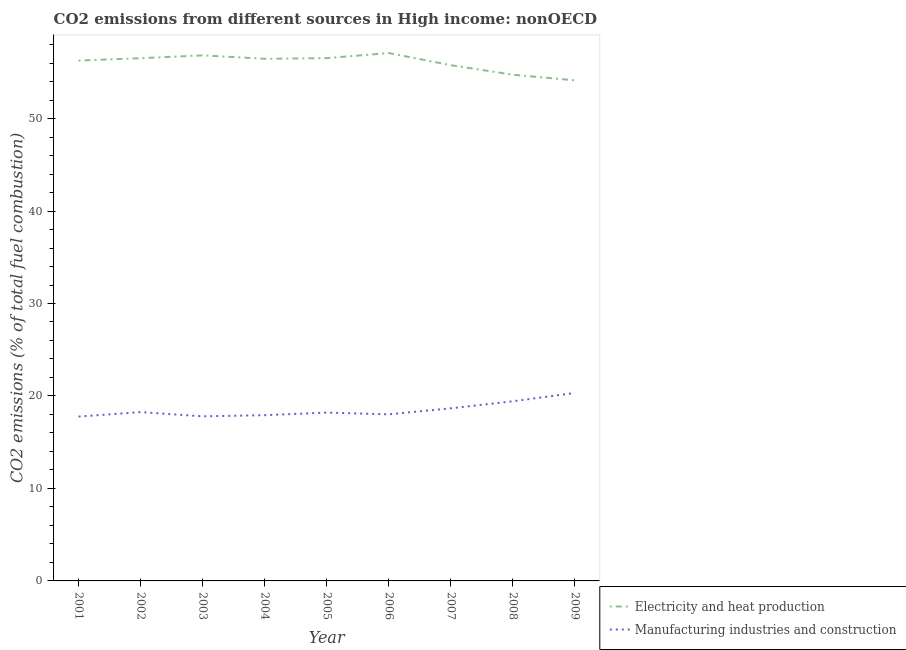What is the co2 emissions due to electricity and heat production in 2002?
Your answer should be very brief. 56.53. Across all years, what is the maximum co2 emissions due to manufacturing industries?
Offer a very short reply. 20.33. Across all years, what is the minimum co2 emissions due to manufacturing industries?
Offer a terse response. 17.77. In which year was the co2 emissions due to electricity and heat production minimum?
Provide a short and direct response. 2009. What is the total co2 emissions due to manufacturing industries in the graph?
Ensure brevity in your answer.  166.4. What is the difference between the co2 emissions due to manufacturing industries in 2006 and that in 2008?
Make the answer very short. -1.41. What is the difference between the co2 emissions due to electricity and heat production in 2004 and the co2 emissions due to manufacturing industries in 2008?
Make the answer very short. 37.03. What is the average co2 emissions due to manufacturing industries per year?
Provide a succinct answer. 18.49. In the year 2009, what is the difference between the co2 emissions due to electricity and heat production and co2 emissions due to manufacturing industries?
Ensure brevity in your answer.  33.8. What is the ratio of the co2 emissions due to electricity and heat production in 2006 to that in 2009?
Your response must be concise. 1.05. Is the co2 emissions due to electricity and heat production in 2005 less than that in 2006?
Your response must be concise. Yes. Is the difference between the co2 emissions due to electricity and heat production in 2003 and 2006 greater than the difference between the co2 emissions due to manufacturing industries in 2003 and 2006?
Keep it short and to the point. No. What is the difference between the highest and the second highest co2 emissions due to manufacturing industries?
Keep it short and to the point. 0.9. What is the difference between the highest and the lowest co2 emissions due to manufacturing industries?
Give a very brief answer. 2.56. In how many years, is the co2 emissions due to manufacturing industries greater than the average co2 emissions due to manufacturing industries taken over all years?
Make the answer very short. 3. Is the sum of the co2 emissions due to manufacturing industries in 2001 and 2003 greater than the maximum co2 emissions due to electricity and heat production across all years?
Ensure brevity in your answer.  No. Is the co2 emissions due to manufacturing industries strictly less than the co2 emissions due to electricity and heat production over the years?
Provide a short and direct response. Yes. How many lines are there?
Provide a succinct answer. 2. How many years are there in the graph?
Make the answer very short. 9. What is the difference between two consecutive major ticks on the Y-axis?
Keep it short and to the point. 10. Are the values on the major ticks of Y-axis written in scientific E-notation?
Keep it short and to the point. No. Does the graph contain any zero values?
Give a very brief answer. No. Where does the legend appear in the graph?
Your response must be concise. Bottom right. How many legend labels are there?
Give a very brief answer. 2. How are the legend labels stacked?
Your response must be concise. Vertical. What is the title of the graph?
Give a very brief answer. CO2 emissions from different sources in High income: nonOECD. What is the label or title of the Y-axis?
Offer a terse response. CO2 emissions (% of total fuel combustion). What is the CO2 emissions (% of total fuel combustion) in Electricity and heat production in 2001?
Offer a terse response. 56.27. What is the CO2 emissions (% of total fuel combustion) of Manufacturing industries and construction in 2001?
Give a very brief answer. 17.77. What is the CO2 emissions (% of total fuel combustion) of Electricity and heat production in 2002?
Give a very brief answer. 56.53. What is the CO2 emissions (% of total fuel combustion) of Manufacturing industries and construction in 2002?
Make the answer very short. 18.26. What is the CO2 emissions (% of total fuel combustion) of Electricity and heat production in 2003?
Your answer should be very brief. 56.83. What is the CO2 emissions (% of total fuel combustion) of Manufacturing industries and construction in 2003?
Ensure brevity in your answer.  17.8. What is the CO2 emissions (% of total fuel combustion) in Electricity and heat production in 2004?
Provide a short and direct response. 56.46. What is the CO2 emissions (% of total fuel combustion) in Manufacturing industries and construction in 2004?
Your answer should be compact. 17.92. What is the CO2 emissions (% of total fuel combustion) in Electricity and heat production in 2005?
Make the answer very short. 56.54. What is the CO2 emissions (% of total fuel combustion) in Manufacturing industries and construction in 2005?
Your answer should be very brief. 18.2. What is the CO2 emissions (% of total fuel combustion) of Electricity and heat production in 2006?
Offer a very short reply. 57.08. What is the CO2 emissions (% of total fuel combustion) of Manufacturing industries and construction in 2006?
Offer a terse response. 18.02. What is the CO2 emissions (% of total fuel combustion) of Electricity and heat production in 2007?
Your answer should be compact. 55.77. What is the CO2 emissions (% of total fuel combustion) of Manufacturing industries and construction in 2007?
Provide a short and direct response. 18.67. What is the CO2 emissions (% of total fuel combustion) of Electricity and heat production in 2008?
Provide a short and direct response. 54.74. What is the CO2 emissions (% of total fuel combustion) in Manufacturing industries and construction in 2008?
Provide a succinct answer. 19.43. What is the CO2 emissions (% of total fuel combustion) of Electricity and heat production in 2009?
Make the answer very short. 54.13. What is the CO2 emissions (% of total fuel combustion) in Manufacturing industries and construction in 2009?
Provide a short and direct response. 20.33. Across all years, what is the maximum CO2 emissions (% of total fuel combustion) in Electricity and heat production?
Your answer should be very brief. 57.08. Across all years, what is the maximum CO2 emissions (% of total fuel combustion) of Manufacturing industries and construction?
Make the answer very short. 20.33. Across all years, what is the minimum CO2 emissions (% of total fuel combustion) in Electricity and heat production?
Provide a short and direct response. 54.13. Across all years, what is the minimum CO2 emissions (% of total fuel combustion) in Manufacturing industries and construction?
Offer a terse response. 17.77. What is the total CO2 emissions (% of total fuel combustion) of Electricity and heat production in the graph?
Ensure brevity in your answer.  504.35. What is the total CO2 emissions (% of total fuel combustion) in Manufacturing industries and construction in the graph?
Ensure brevity in your answer.  166.4. What is the difference between the CO2 emissions (% of total fuel combustion) in Electricity and heat production in 2001 and that in 2002?
Your answer should be compact. -0.25. What is the difference between the CO2 emissions (% of total fuel combustion) in Manufacturing industries and construction in 2001 and that in 2002?
Your answer should be compact. -0.48. What is the difference between the CO2 emissions (% of total fuel combustion) of Electricity and heat production in 2001 and that in 2003?
Your answer should be very brief. -0.56. What is the difference between the CO2 emissions (% of total fuel combustion) in Manufacturing industries and construction in 2001 and that in 2003?
Your response must be concise. -0.03. What is the difference between the CO2 emissions (% of total fuel combustion) of Electricity and heat production in 2001 and that in 2004?
Give a very brief answer. -0.19. What is the difference between the CO2 emissions (% of total fuel combustion) of Manufacturing industries and construction in 2001 and that in 2004?
Your answer should be compact. -0.15. What is the difference between the CO2 emissions (% of total fuel combustion) of Electricity and heat production in 2001 and that in 2005?
Offer a terse response. -0.27. What is the difference between the CO2 emissions (% of total fuel combustion) of Manufacturing industries and construction in 2001 and that in 2005?
Keep it short and to the point. -0.43. What is the difference between the CO2 emissions (% of total fuel combustion) of Electricity and heat production in 2001 and that in 2006?
Keep it short and to the point. -0.81. What is the difference between the CO2 emissions (% of total fuel combustion) in Manufacturing industries and construction in 2001 and that in 2006?
Your response must be concise. -0.24. What is the difference between the CO2 emissions (% of total fuel combustion) in Electricity and heat production in 2001 and that in 2007?
Offer a very short reply. 0.5. What is the difference between the CO2 emissions (% of total fuel combustion) in Manufacturing industries and construction in 2001 and that in 2007?
Ensure brevity in your answer.  -0.9. What is the difference between the CO2 emissions (% of total fuel combustion) of Electricity and heat production in 2001 and that in 2008?
Keep it short and to the point. 1.53. What is the difference between the CO2 emissions (% of total fuel combustion) in Manufacturing industries and construction in 2001 and that in 2008?
Your answer should be compact. -1.66. What is the difference between the CO2 emissions (% of total fuel combustion) in Electricity and heat production in 2001 and that in 2009?
Offer a terse response. 2.14. What is the difference between the CO2 emissions (% of total fuel combustion) of Manufacturing industries and construction in 2001 and that in 2009?
Your answer should be compact. -2.56. What is the difference between the CO2 emissions (% of total fuel combustion) of Electricity and heat production in 2002 and that in 2003?
Offer a terse response. -0.31. What is the difference between the CO2 emissions (% of total fuel combustion) of Manufacturing industries and construction in 2002 and that in 2003?
Provide a short and direct response. 0.46. What is the difference between the CO2 emissions (% of total fuel combustion) in Electricity and heat production in 2002 and that in 2004?
Make the answer very short. 0.06. What is the difference between the CO2 emissions (% of total fuel combustion) in Manufacturing industries and construction in 2002 and that in 2004?
Your answer should be compact. 0.33. What is the difference between the CO2 emissions (% of total fuel combustion) in Electricity and heat production in 2002 and that in 2005?
Make the answer very short. -0.01. What is the difference between the CO2 emissions (% of total fuel combustion) of Manufacturing industries and construction in 2002 and that in 2005?
Your answer should be compact. 0.05. What is the difference between the CO2 emissions (% of total fuel combustion) of Electricity and heat production in 2002 and that in 2006?
Give a very brief answer. -0.56. What is the difference between the CO2 emissions (% of total fuel combustion) in Manufacturing industries and construction in 2002 and that in 2006?
Offer a very short reply. 0.24. What is the difference between the CO2 emissions (% of total fuel combustion) of Electricity and heat production in 2002 and that in 2007?
Offer a terse response. 0.76. What is the difference between the CO2 emissions (% of total fuel combustion) of Manufacturing industries and construction in 2002 and that in 2007?
Make the answer very short. -0.41. What is the difference between the CO2 emissions (% of total fuel combustion) in Electricity and heat production in 2002 and that in 2008?
Make the answer very short. 1.79. What is the difference between the CO2 emissions (% of total fuel combustion) of Manufacturing industries and construction in 2002 and that in 2008?
Provide a short and direct response. -1.17. What is the difference between the CO2 emissions (% of total fuel combustion) of Electricity and heat production in 2002 and that in 2009?
Your answer should be very brief. 2.4. What is the difference between the CO2 emissions (% of total fuel combustion) of Manufacturing industries and construction in 2002 and that in 2009?
Provide a short and direct response. -2.07. What is the difference between the CO2 emissions (% of total fuel combustion) in Electricity and heat production in 2003 and that in 2004?
Your answer should be compact. 0.37. What is the difference between the CO2 emissions (% of total fuel combustion) in Manufacturing industries and construction in 2003 and that in 2004?
Provide a succinct answer. -0.12. What is the difference between the CO2 emissions (% of total fuel combustion) in Electricity and heat production in 2003 and that in 2005?
Ensure brevity in your answer.  0.3. What is the difference between the CO2 emissions (% of total fuel combustion) in Manufacturing industries and construction in 2003 and that in 2005?
Offer a terse response. -0.4. What is the difference between the CO2 emissions (% of total fuel combustion) of Electricity and heat production in 2003 and that in 2006?
Ensure brevity in your answer.  -0.25. What is the difference between the CO2 emissions (% of total fuel combustion) of Manufacturing industries and construction in 2003 and that in 2006?
Your response must be concise. -0.22. What is the difference between the CO2 emissions (% of total fuel combustion) of Electricity and heat production in 2003 and that in 2007?
Your answer should be compact. 1.06. What is the difference between the CO2 emissions (% of total fuel combustion) of Manufacturing industries and construction in 2003 and that in 2007?
Your answer should be compact. -0.87. What is the difference between the CO2 emissions (% of total fuel combustion) in Electricity and heat production in 2003 and that in 2008?
Ensure brevity in your answer.  2.09. What is the difference between the CO2 emissions (% of total fuel combustion) of Manufacturing industries and construction in 2003 and that in 2008?
Make the answer very short. -1.63. What is the difference between the CO2 emissions (% of total fuel combustion) of Electricity and heat production in 2003 and that in 2009?
Your answer should be very brief. 2.7. What is the difference between the CO2 emissions (% of total fuel combustion) of Manufacturing industries and construction in 2003 and that in 2009?
Your response must be concise. -2.53. What is the difference between the CO2 emissions (% of total fuel combustion) of Electricity and heat production in 2004 and that in 2005?
Your answer should be very brief. -0.07. What is the difference between the CO2 emissions (% of total fuel combustion) in Manufacturing industries and construction in 2004 and that in 2005?
Your answer should be very brief. -0.28. What is the difference between the CO2 emissions (% of total fuel combustion) of Electricity and heat production in 2004 and that in 2006?
Provide a short and direct response. -0.62. What is the difference between the CO2 emissions (% of total fuel combustion) of Manufacturing industries and construction in 2004 and that in 2006?
Provide a short and direct response. -0.09. What is the difference between the CO2 emissions (% of total fuel combustion) in Electricity and heat production in 2004 and that in 2007?
Provide a short and direct response. 0.7. What is the difference between the CO2 emissions (% of total fuel combustion) of Manufacturing industries and construction in 2004 and that in 2007?
Ensure brevity in your answer.  -0.74. What is the difference between the CO2 emissions (% of total fuel combustion) in Electricity and heat production in 2004 and that in 2008?
Your response must be concise. 1.73. What is the difference between the CO2 emissions (% of total fuel combustion) in Manufacturing industries and construction in 2004 and that in 2008?
Provide a short and direct response. -1.51. What is the difference between the CO2 emissions (% of total fuel combustion) of Electricity and heat production in 2004 and that in 2009?
Your answer should be very brief. 2.33. What is the difference between the CO2 emissions (% of total fuel combustion) of Manufacturing industries and construction in 2004 and that in 2009?
Make the answer very short. -2.41. What is the difference between the CO2 emissions (% of total fuel combustion) of Electricity and heat production in 2005 and that in 2006?
Give a very brief answer. -0.55. What is the difference between the CO2 emissions (% of total fuel combustion) of Manufacturing industries and construction in 2005 and that in 2006?
Your response must be concise. 0.19. What is the difference between the CO2 emissions (% of total fuel combustion) in Electricity and heat production in 2005 and that in 2007?
Give a very brief answer. 0.77. What is the difference between the CO2 emissions (% of total fuel combustion) in Manufacturing industries and construction in 2005 and that in 2007?
Provide a short and direct response. -0.46. What is the difference between the CO2 emissions (% of total fuel combustion) of Electricity and heat production in 2005 and that in 2008?
Keep it short and to the point. 1.8. What is the difference between the CO2 emissions (% of total fuel combustion) in Manufacturing industries and construction in 2005 and that in 2008?
Provide a succinct answer. -1.23. What is the difference between the CO2 emissions (% of total fuel combustion) of Electricity and heat production in 2005 and that in 2009?
Provide a short and direct response. 2.41. What is the difference between the CO2 emissions (% of total fuel combustion) of Manufacturing industries and construction in 2005 and that in 2009?
Your answer should be very brief. -2.13. What is the difference between the CO2 emissions (% of total fuel combustion) of Electricity and heat production in 2006 and that in 2007?
Offer a terse response. 1.31. What is the difference between the CO2 emissions (% of total fuel combustion) in Manufacturing industries and construction in 2006 and that in 2007?
Offer a very short reply. -0.65. What is the difference between the CO2 emissions (% of total fuel combustion) in Electricity and heat production in 2006 and that in 2008?
Ensure brevity in your answer.  2.34. What is the difference between the CO2 emissions (% of total fuel combustion) of Manufacturing industries and construction in 2006 and that in 2008?
Offer a very short reply. -1.41. What is the difference between the CO2 emissions (% of total fuel combustion) of Electricity and heat production in 2006 and that in 2009?
Ensure brevity in your answer.  2.95. What is the difference between the CO2 emissions (% of total fuel combustion) in Manufacturing industries and construction in 2006 and that in 2009?
Offer a very short reply. -2.31. What is the difference between the CO2 emissions (% of total fuel combustion) in Manufacturing industries and construction in 2007 and that in 2008?
Offer a terse response. -0.76. What is the difference between the CO2 emissions (% of total fuel combustion) in Electricity and heat production in 2007 and that in 2009?
Your answer should be compact. 1.64. What is the difference between the CO2 emissions (% of total fuel combustion) in Manufacturing industries and construction in 2007 and that in 2009?
Provide a short and direct response. -1.66. What is the difference between the CO2 emissions (% of total fuel combustion) of Electricity and heat production in 2008 and that in 2009?
Make the answer very short. 0.61. What is the difference between the CO2 emissions (% of total fuel combustion) of Manufacturing industries and construction in 2008 and that in 2009?
Ensure brevity in your answer.  -0.9. What is the difference between the CO2 emissions (% of total fuel combustion) of Electricity and heat production in 2001 and the CO2 emissions (% of total fuel combustion) of Manufacturing industries and construction in 2002?
Offer a very short reply. 38.02. What is the difference between the CO2 emissions (% of total fuel combustion) in Electricity and heat production in 2001 and the CO2 emissions (% of total fuel combustion) in Manufacturing industries and construction in 2003?
Your response must be concise. 38.47. What is the difference between the CO2 emissions (% of total fuel combustion) in Electricity and heat production in 2001 and the CO2 emissions (% of total fuel combustion) in Manufacturing industries and construction in 2004?
Your answer should be compact. 38.35. What is the difference between the CO2 emissions (% of total fuel combustion) of Electricity and heat production in 2001 and the CO2 emissions (% of total fuel combustion) of Manufacturing industries and construction in 2005?
Make the answer very short. 38.07. What is the difference between the CO2 emissions (% of total fuel combustion) in Electricity and heat production in 2001 and the CO2 emissions (% of total fuel combustion) in Manufacturing industries and construction in 2006?
Make the answer very short. 38.26. What is the difference between the CO2 emissions (% of total fuel combustion) of Electricity and heat production in 2001 and the CO2 emissions (% of total fuel combustion) of Manufacturing industries and construction in 2007?
Ensure brevity in your answer.  37.6. What is the difference between the CO2 emissions (% of total fuel combustion) in Electricity and heat production in 2001 and the CO2 emissions (% of total fuel combustion) in Manufacturing industries and construction in 2008?
Your answer should be very brief. 36.84. What is the difference between the CO2 emissions (% of total fuel combustion) of Electricity and heat production in 2001 and the CO2 emissions (% of total fuel combustion) of Manufacturing industries and construction in 2009?
Offer a very short reply. 35.94. What is the difference between the CO2 emissions (% of total fuel combustion) in Electricity and heat production in 2002 and the CO2 emissions (% of total fuel combustion) in Manufacturing industries and construction in 2003?
Offer a very short reply. 38.73. What is the difference between the CO2 emissions (% of total fuel combustion) of Electricity and heat production in 2002 and the CO2 emissions (% of total fuel combustion) of Manufacturing industries and construction in 2004?
Give a very brief answer. 38.6. What is the difference between the CO2 emissions (% of total fuel combustion) of Electricity and heat production in 2002 and the CO2 emissions (% of total fuel combustion) of Manufacturing industries and construction in 2005?
Your answer should be very brief. 38.32. What is the difference between the CO2 emissions (% of total fuel combustion) of Electricity and heat production in 2002 and the CO2 emissions (% of total fuel combustion) of Manufacturing industries and construction in 2006?
Offer a very short reply. 38.51. What is the difference between the CO2 emissions (% of total fuel combustion) of Electricity and heat production in 2002 and the CO2 emissions (% of total fuel combustion) of Manufacturing industries and construction in 2007?
Your answer should be compact. 37.86. What is the difference between the CO2 emissions (% of total fuel combustion) in Electricity and heat production in 2002 and the CO2 emissions (% of total fuel combustion) in Manufacturing industries and construction in 2008?
Ensure brevity in your answer.  37.1. What is the difference between the CO2 emissions (% of total fuel combustion) of Electricity and heat production in 2002 and the CO2 emissions (% of total fuel combustion) of Manufacturing industries and construction in 2009?
Provide a short and direct response. 36.2. What is the difference between the CO2 emissions (% of total fuel combustion) of Electricity and heat production in 2003 and the CO2 emissions (% of total fuel combustion) of Manufacturing industries and construction in 2004?
Provide a succinct answer. 38.91. What is the difference between the CO2 emissions (% of total fuel combustion) of Electricity and heat production in 2003 and the CO2 emissions (% of total fuel combustion) of Manufacturing industries and construction in 2005?
Your answer should be compact. 38.63. What is the difference between the CO2 emissions (% of total fuel combustion) in Electricity and heat production in 2003 and the CO2 emissions (% of total fuel combustion) in Manufacturing industries and construction in 2006?
Provide a short and direct response. 38.82. What is the difference between the CO2 emissions (% of total fuel combustion) of Electricity and heat production in 2003 and the CO2 emissions (% of total fuel combustion) of Manufacturing industries and construction in 2007?
Offer a terse response. 38.17. What is the difference between the CO2 emissions (% of total fuel combustion) in Electricity and heat production in 2003 and the CO2 emissions (% of total fuel combustion) in Manufacturing industries and construction in 2008?
Provide a succinct answer. 37.4. What is the difference between the CO2 emissions (% of total fuel combustion) of Electricity and heat production in 2003 and the CO2 emissions (% of total fuel combustion) of Manufacturing industries and construction in 2009?
Give a very brief answer. 36.5. What is the difference between the CO2 emissions (% of total fuel combustion) of Electricity and heat production in 2004 and the CO2 emissions (% of total fuel combustion) of Manufacturing industries and construction in 2005?
Give a very brief answer. 38.26. What is the difference between the CO2 emissions (% of total fuel combustion) in Electricity and heat production in 2004 and the CO2 emissions (% of total fuel combustion) in Manufacturing industries and construction in 2006?
Provide a short and direct response. 38.45. What is the difference between the CO2 emissions (% of total fuel combustion) in Electricity and heat production in 2004 and the CO2 emissions (% of total fuel combustion) in Manufacturing industries and construction in 2007?
Give a very brief answer. 37.8. What is the difference between the CO2 emissions (% of total fuel combustion) of Electricity and heat production in 2004 and the CO2 emissions (% of total fuel combustion) of Manufacturing industries and construction in 2008?
Keep it short and to the point. 37.03. What is the difference between the CO2 emissions (% of total fuel combustion) in Electricity and heat production in 2004 and the CO2 emissions (% of total fuel combustion) in Manufacturing industries and construction in 2009?
Keep it short and to the point. 36.14. What is the difference between the CO2 emissions (% of total fuel combustion) of Electricity and heat production in 2005 and the CO2 emissions (% of total fuel combustion) of Manufacturing industries and construction in 2006?
Keep it short and to the point. 38.52. What is the difference between the CO2 emissions (% of total fuel combustion) of Electricity and heat production in 2005 and the CO2 emissions (% of total fuel combustion) of Manufacturing industries and construction in 2007?
Offer a very short reply. 37.87. What is the difference between the CO2 emissions (% of total fuel combustion) in Electricity and heat production in 2005 and the CO2 emissions (% of total fuel combustion) in Manufacturing industries and construction in 2008?
Ensure brevity in your answer.  37.11. What is the difference between the CO2 emissions (% of total fuel combustion) in Electricity and heat production in 2005 and the CO2 emissions (% of total fuel combustion) in Manufacturing industries and construction in 2009?
Your answer should be very brief. 36.21. What is the difference between the CO2 emissions (% of total fuel combustion) of Electricity and heat production in 2006 and the CO2 emissions (% of total fuel combustion) of Manufacturing industries and construction in 2007?
Make the answer very short. 38.42. What is the difference between the CO2 emissions (% of total fuel combustion) in Electricity and heat production in 2006 and the CO2 emissions (% of total fuel combustion) in Manufacturing industries and construction in 2008?
Your response must be concise. 37.65. What is the difference between the CO2 emissions (% of total fuel combustion) in Electricity and heat production in 2006 and the CO2 emissions (% of total fuel combustion) in Manufacturing industries and construction in 2009?
Your response must be concise. 36.75. What is the difference between the CO2 emissions (% of total fuel combustion) of Electricity and heat production in 2007 and the CO2 emissions (% of total fuel combustion) of Manufacturing industries and construction in 2008?
Provide a short and direct response. 36.34. What is the difference between the CO2 emissions (% of total fuel combustion) in Electricity and heat production in 2007 and the CO2 emissions (% of total fuel combustion) in Manufacturing industries and construction in 2009?
Offer a very short reply. 35.44. What is the difference between the CO2 emissions (% of total fuel combustion) in Electricity and heat production in 2008 and the CO2 emissions (% of total fuel combustion) in Manufacturing industries and construction in 2009?
Your answer should be very brief. 34.41. What is the average CO2 emissions (% of total fuel combustion) of Electricity and heat production per year?
Provide a succinct answer. 56.04. What is the average CO2 emissions (% of total fuel combustion) of Manufacturing industries and construction per year?
Keep it short and to the point. 18.49. In the year 2001, what is the difference between the CO2 emissions (% of total fuel combustion) in Electricity and heat production and CO2 emissions (% of total fuel combustion) in Manufacturing industries and construction?
Your answer should be very brief. 38.5. In the year 2002, what is the difference between the CO2 emissions (% of total fuel combustion) in Electricity and heat production and CO2 emissions (% of total fuel combustion) in Manufacturing industries and construction?
Your answer should be very brief. 38.27. In the year 2003, what is the difference between the CO2 emissions (% of total fuel combustion) of Electricity and heat production and CO2 emissions (% of total fuel combustion) of Manufacturing industries and construction?
Your response must be concise. 39.03. In the year 2004, what is the difference between the CO2 emissions (% of total fuel combustion) in Electricity and heat production and CO2 emissions (% of total fuel combustion) in Manufacturing industries and construction?
Give a very brief answer. 38.54. In the year 2005, what is the difference between the CO2 emissions (% of total fuel combustion) of Electricity and heat production and CO2 emissions (% of total fuel combustion) of Manufacturing industries and construction?
Your answer should be compact. 38.33. In the year 2006, what is the difference between the CO2 emissions (% of total fuel combustion) in Electricity and heat production and CO2 emissions (% of total fuel combustion) in Manufacturing industries and construction?
Your response must be concise. 39.07. In the year 2007, what is the difference between the CO2 emissions (% of total fuel combustion) in Electricity and heat production and CO2 emissions (% of total fuel combustion) in Manufacturing industries and construction?
Offer a very short reply. 37.1. In the year 2008, what is the difference between the CO2 emissions (% of total fuel combustion) in Electricity and heat production and CO2 emissions (% of total fuel combustion) in Manufacturing industries and construction?
Offer a terse response. 35.31. In the year 2009, what is the difference between the CO2 emissions (% of total fuel combustion) of Electricity and heat production and CO2 emissions (% of total fuel combustion) of Manufacturing industries and construction?
Give a very brief answer. 33.8. What is the ratio of the CO2 emissions (% of total fuel combustion) in Electricity and heat production in 2001 to that in 2002?
Your answer should be compact. 1. What is the ratio of the CO2 emissions (% of total fuel combustion) of Manufacturing industries and construction in 2001 to that in 2002?
Offer a very short reply. 0.97. What is the ratio of the CO2 emissions (% of total fuel combustion) in Manufacturing industries and construction in 2001 to that in 2005?
Offer a terse response. 0.98. What is the ratio of the CO2 emissions (% of total fuel combustion) in Electricity and heat production in 2001 to that in 2006?
Offer a terse response. 0.99. What is the ratio of the CO2 emissions (% of total fuel combustion) in Manufacturing industries and construction in 2001 to that in 2006?
Offer a very short reply. 0.99. What is the ratio of the CO2 emissions (% of total fuel combustion) in Electricity and heat production in 2001 to that in 2007?
Provide a short and direct response. 1.01. What is the ratio of the CO2 emissions (% of total fuel combustion) of Manufacturing industries and construction in 2001 to that in 2007?
Provide a succinct answer. 0.95. What is the ratio of the CO2 emissions (% of total fuel combustion) in Electricity and heat production in 2001 to that in 2008?
Offer a very short reply. 1.03. What is the ratio of the CO2 emissions (% of total fuel combustion) in Manufacturing industries and construction in 2001 to that in 2008?
Provide a succinct answer. 0.91. What is the ratio of the CO2 emissions (% of total fuel combustion) of Electricity and heat production in 2001 to that in 2009?
Your answer should be very brief. 1.04. What is the ratio of the CO2 emissions (% of total fuel combustion) of Manufacturing industries and construction in 2001 to that in 2009?
Offer a terse response. 0.87. What is the ratio of the CO2 emissions (% of total fuel combustion) in Manufacturing industries and construction in 2002 to that in 2003?
Your answer should be very brief. 1.03. What is the ratio of the CO2 emissions (% of total fuel combustion) in Manufacturing industries and construction in 2002 to that in 2004?
Provide a short and direct response. 1.02. What is the ratio of the CO2 emissions (% of total fuel combustion) in Electricity and heat production in 2002 to that in 2005?
Offer a terse response. 1. What is the ratio of the CO2 emissions (% of total fuel combustion) of Electricity and heat production in 2002 to that in 2006?
Provide a short and direct response. 0.99. What is the ratio of the CO2 emissions (% of total fuel combustion) in Manufacturing industries and construction in 2002 to that in 2006?
Provide a short and direct response. 1.01. What is the ratio of the CO2 emissions (% of total fuel combustion) in Electricity and heat production in 2002 to that in 2007?
Your answer should be compact. 1.01. What is the ratio of the CO2 emissions (% of total fuel combustion) in Manufacturing industries and construction in 2002 to that in 2007?
Give a very brief answer. 0.98. What is the ratio of the CO2 emissions (% of total fuel combustion) in Electricity and heat production in 2002 to that in 2008?
Provide a short and direct response. 1.03. What is the ratio of the CO2 emissions (% of total fuel combustion) of Manufacturing industries and construction in 2002 to that in 2008?
Your answer should be very brief. 0.94. What is the ratio of the CO2 emissions (% of total fuel combustion) of Electricity and heat production in 2002 to that in 2009?
Offer a very short reply. 1.04. What is the ratio of the CO2 emissions (% of total fuel combustion) in Manufacturing industries and construction in 2002 to that in 2009?
Ensure brevity in your answer.  0.9. What is the ratio of the CO2 emissions (% of total fuel combustion) in Electricity and heat production in 2003 to that in 2004?
Give a very brief answer. 1.01. What is the ratio of the CO2 emissions (% of total fuel combustion) in Manufacturing industries and construction in 2003 to that in 2004?
Your response must be concise. 0.99. What is the ratio of the CO2 emissions (% of total fuel combustion) of Manufacturing industries and construction in 2003 to that in 2005?
Your response must be concise. 0.98. What is the ratio of the CO2 emissions (% of total fuel combustion) in Electricity and heat production in 2003 to that in 2006?
Offer a terse response. 1. What is the ratio of the CO2 emissions (% of total fuel combustion) of Manufacturing industries and construction in 2003 to that in 2006?
Provide a short and direct response. 0.99. What is the ratio of the CO2 emissions (% of total fuel combustion) of Electricity and heat production in 2003 to that in 2007?
Your response must be concise. 1.02. What is the ratio of the CO2 emissions (% of total fuel combustion) of Manufacturing industries and construction in 2003 to that in 2007?
Your answer should be very brief. 0.95. What is the ratio of the CO2 emissions (% of total fuel combustion) in Electricity and heat production in 2003 to that in 2008?
Your answer should be very brief. 1.04. What is the ratio of the CO2 emissions (% of total fuel combustion) of Manufacturing industries and construction in 2003 to that in 2008?
Your answer should be very brief. 0.92. What is the ratio of the CO2 emissions (% of total fuel combustion) in Electricity and heat production in 2003 to that in 2009?
Your answer should be very brief. 1.05. What is the ratio of the CO2 emissions (% of total fuel combustion) of Manufacturing industries and construction in 2003 to that in 2009?
Provide a short and direct response. 0.88. What is the ratio of the CO2 emissions (% of total fuel combustion) in Electricity and heat production in 2004 to that in 2005?
Your answer should be very brief. 1. What is the ratio of the CO2 emissions (% of total fuel combustion) of Manufacturing industries and construction in 2004 to that in 2005?
Your answer should be compact. 0.98. What is the ratio of the CO2 emissions (% of total fuel combustion) of Manufacturing industries and construction in 2004 to that in 2006?
Keep it short and to the point. 0.99. What is the ratio of the CO2 emissions (% of total fuel combustion) of Electricity and heat production in 2004 to that in 2007?
Provide a short and direct response. 1.01. What is the ratio of the CO2 emissions (% of total fuel combustion) in Manufacturing industries and construction in 2004 to that in 2007?
Make the answer very short. 0.96. What is the ratio of the CO2 emissions (% of total fuel combustion) in Electricity and heat production in 2004 to that in 2008?
Your answer should be compact. 1.03. What is the ratio of the CO2 emissions (% of total fuel combustion) in Manufacturing industries and construction in 2004 to that in 2008?
Give a very brief answer. 0.92. What is the ratio of the CO2 emissions (% of total fuel combustion) of Electricity and heat production in 2004 to that in 2009?
Keep it short and to the point. 1.04. What is the ratio of the CO2 emissions (% of total fuel combustion) in Manufacturing industries and construction in 2004 to that in 2009?
Provide a succinct answer. 0.88. What is the ratio of the CO2 emissions (% of total fuel combustion) of Manufacturing industries and construction in 2005 to that in 2006?
Ensure brevity in your answer.  1.01. What is the ratio of the CO2 emissions (% of total fuel combustion) in Electricity and heat production in 2005 to that in 2007?
Provide a short and direct response. 1.01. What is the ratio of the CO2 emissions (% of total fuel combustion) of Manufacturing industries and construction in 2005 to that in 2007?
Provide a short and direct response. 0.98. What is the ratio of the CO2 emissions (% of total fuel combustion) in Electricity and heat production in 2005 to that in 2008?
Ensure brevity in your answer.  1.03. What is the ratio of the CO2 emissions (% of total fuel combustion) in Manufacturing industries and construction in 2005 to that in 2008?
Your response must be concise. 0.94. What is the ratio of the CO2 emissions (% of total fuel combustion) in Electricity and heat production in 2005 to that in 2009?
Keep it short and to the point. 1.04. What is the ratio of the CO2 emissions (% of total fuel combustion) in Manufacturing industries and construction in 2005 to that in 2009?
Provide a succinct answer. 0.9. What is the ratio of the CO2 emissions (% of total fuel combustion) of Electricity and heat production in 2006 to that in 2007?
Offer a terse response. 1.02. What is the ratio of the CO2 emissions (% of total fuel combustion) in Manufacturing industries and construction in 2006 to that in 2007?
Your answer should be very brief. 0.97. What is the ratio of the CO2 emissions (% of total fuel combustion) of Electricity and heat production in 2006 to that in 2008?
Provide a short and direct response. 1.04. What is the ratio of the CO2 emissions (% of total fuel combustion) of Manufacturing industries and construction in 2006 to that in 2008?
Make the answer very short. 0.93. What is the ratio of the CO2 emissions (% of total fuel combustion) in Electricity and heat production in 2006 to that in 2009?
Keep it short and to the point. 1.05. What is the ratio of the CO2 emissions (% of total fuel combustion) of Manufacturing industries and construction in 2006 to that in 2009?
Provide a succinct answer. 0.89. What is the ratio of the CO2 emissions (% of total fuel combustion) in Electricity and heat production in 2007 to that in 2008?
Your answer should be compact. 1.02. What is the ratio of the CO2 emissions (% of total fuel combustion) in Manufacturing industries and construction in 2007 to that in 2008?
Give a very brief answer. 0.96. What is the ratio of the CO2 emissions (% of total fuel combustion) of Electricity and heat production in 2007 to that in 2009?
Ensure brevity in your answer.  1.03. What is the ratio of the CO2 emissions (% of total fuel combustion) in Manufacturing industries and construction in 2007 to that in 2009?
Provide a succinct answer. 0.92. What is the ratio of the CO2 emissions (% of total fuel combustion) of Electricity and heat production in 2008 to that in 2009?
Ensure brevity in your answer.  1.01. What is the ratio of the CO2 emissions (% of total fuel combustion) of Manufacturing industries and construction in 2008 to that in 2009?
Make the answer very short. 0.96. What is the difference between the highest and the second highest CO2 emissions (% of total fuel combustion) of Electricity and heat production?
Your answer should be compact. 0.25. What is the difference between the highest and the second highest CO2 emissions (% of total fuel combustion) in Manufacturing industries and construction?
Keep it short and to the point. 0.9. What is the difference between the highest and the lowest CO2 emissions (% of total fuel combustion) in Electricity and heat production?
Your answer should be compact. 2.95. What is the difference between the highest and the lowest CO2 emissions (% of total fuel combustion) of Manufacturing industries and construction?
Ensure brevity in your answer.  2.56. 